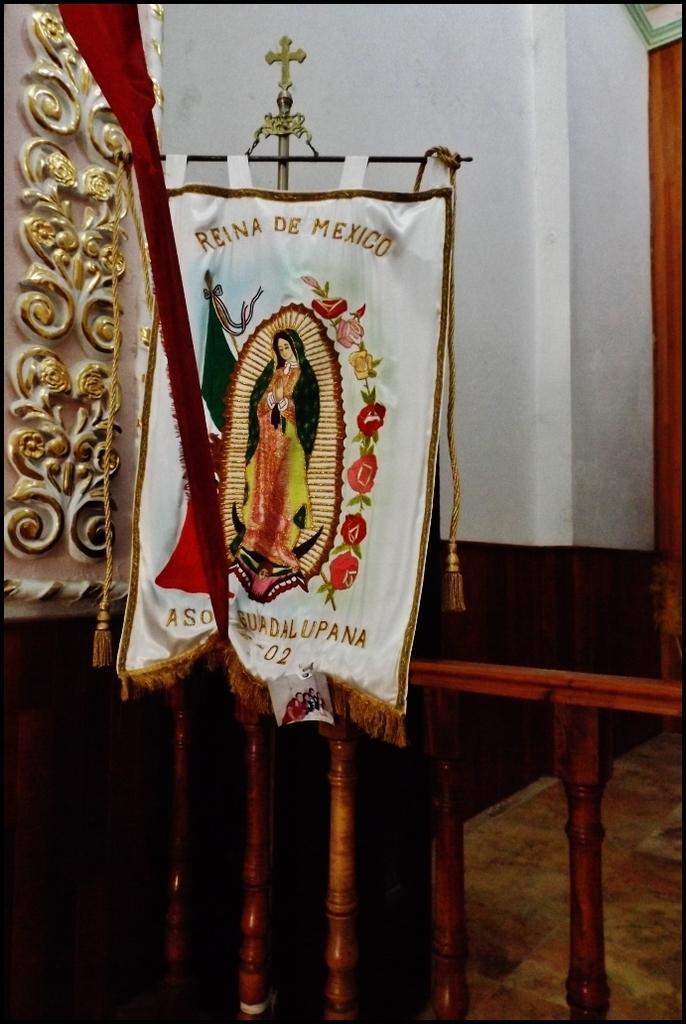How would you summarize this image in a sentence or two? In this image I can see the cloth and I can see the person and the flowers in the cloth. I can see the railing and the wall in the back. 